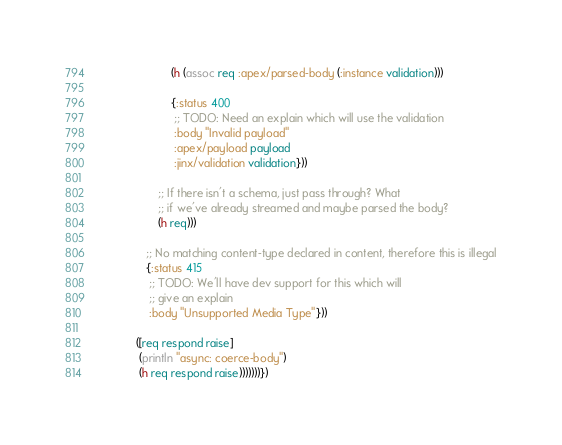<code> <loc_0><loc_0><loc_500><loc_500><_Clojure_>                        (h (assoc req :apex/parsed-body (:instance validation)))

                        {:status 400
                         ;; TODO: Need an explain which will use the validation
                         :body "Invalid payload"
                         :apex/payload payload
                         :jinx/validation validation}))

                    ;; If there isn't a schema, just pass through? What
                    ;; if we've already streamed and maybe parsed the body?
                    (h req)))

                ;; No matching content-type declared in content, therefore this is illegal
                {:status 415
                 ;; TODO: We'll have dev support for this which will
                 ;; give an explain
                 :body "Unsupported Media Type"}))

             ([req respond raise]
              (println "async: coerce-body")
              (h req respond raise)))))))})
</code> 